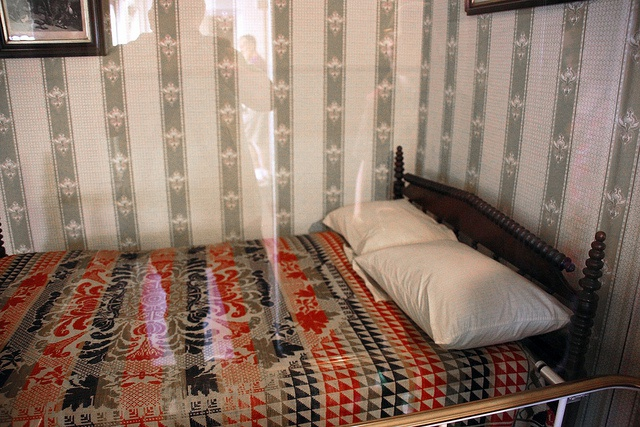Describe the objects in this image and their specific colors. I can see a bed in gray, black, and maroon tones in this image. 